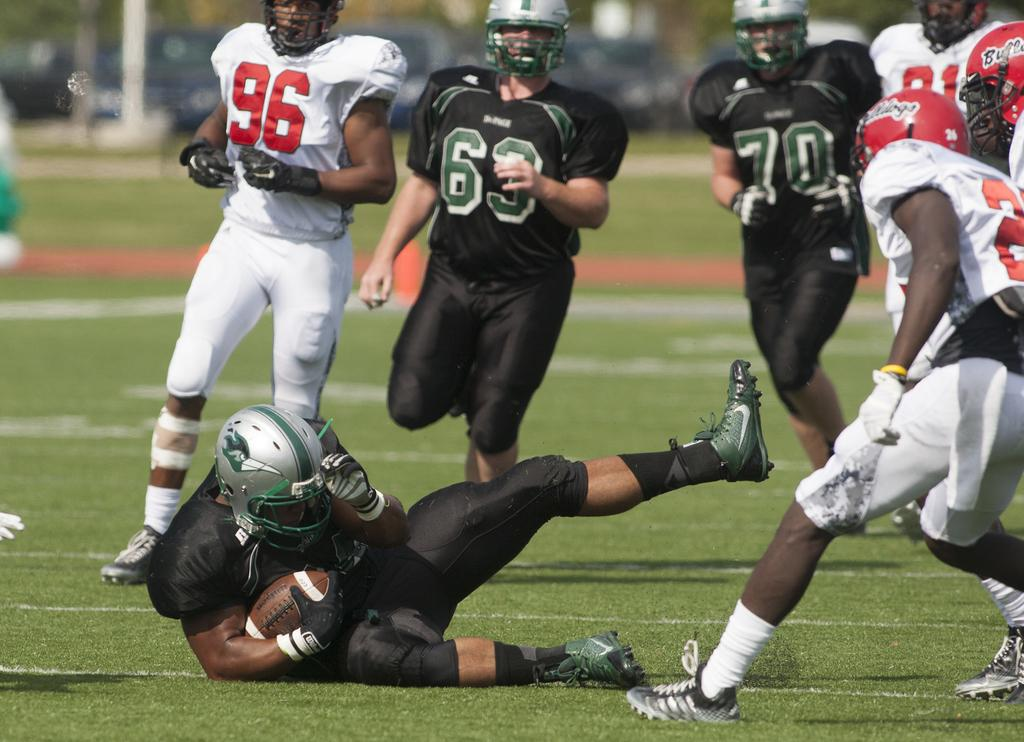What activity are the people in the image engaged in? The people in the image are playing a game. Can you describe the position of the man in the image? The man is sitting on the ground in the image. What object is the man holding in the image? The man is holding a ball in the image. What type of cave can be seen in the background of the image? There is no cave present in the image; it features people playing a game and a man holding a ball. 